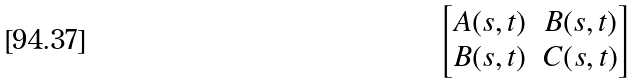<formula> <loc_0><loc_0><loc_500><loc_500>\begin{bmatrix} A ( s , t ) & B ( s , t ) \\ B ( s , t ) & C ( s , t ) \end{bmatrix}</formula> 